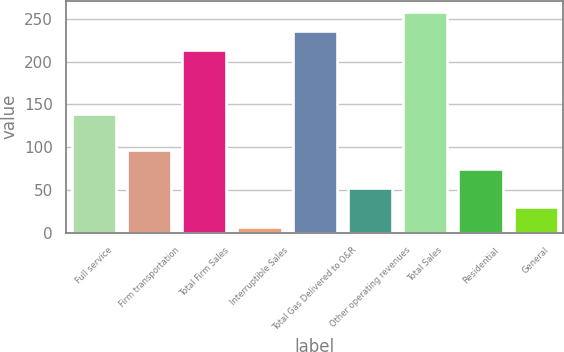Convert chart to OTSL. <chart><loc_0><loc_0><loc_500><loc_500><bar_chart><fcel>Full service<fcel>Firm transportation<fcel>Total Firm Sales<fcel>Interruptible Sales<fcel>Total Gas Delivered to O&R<fcel>Other operating revenues<fcel>Total Sales<fcel>Residential<fcel>General<nl><fcel>139<fcel>97<fcel>213<fcel>7<fcel>235.5<fcel>52<fcel>258<fcel>74.5<fcel>29.5<nl></chart> 